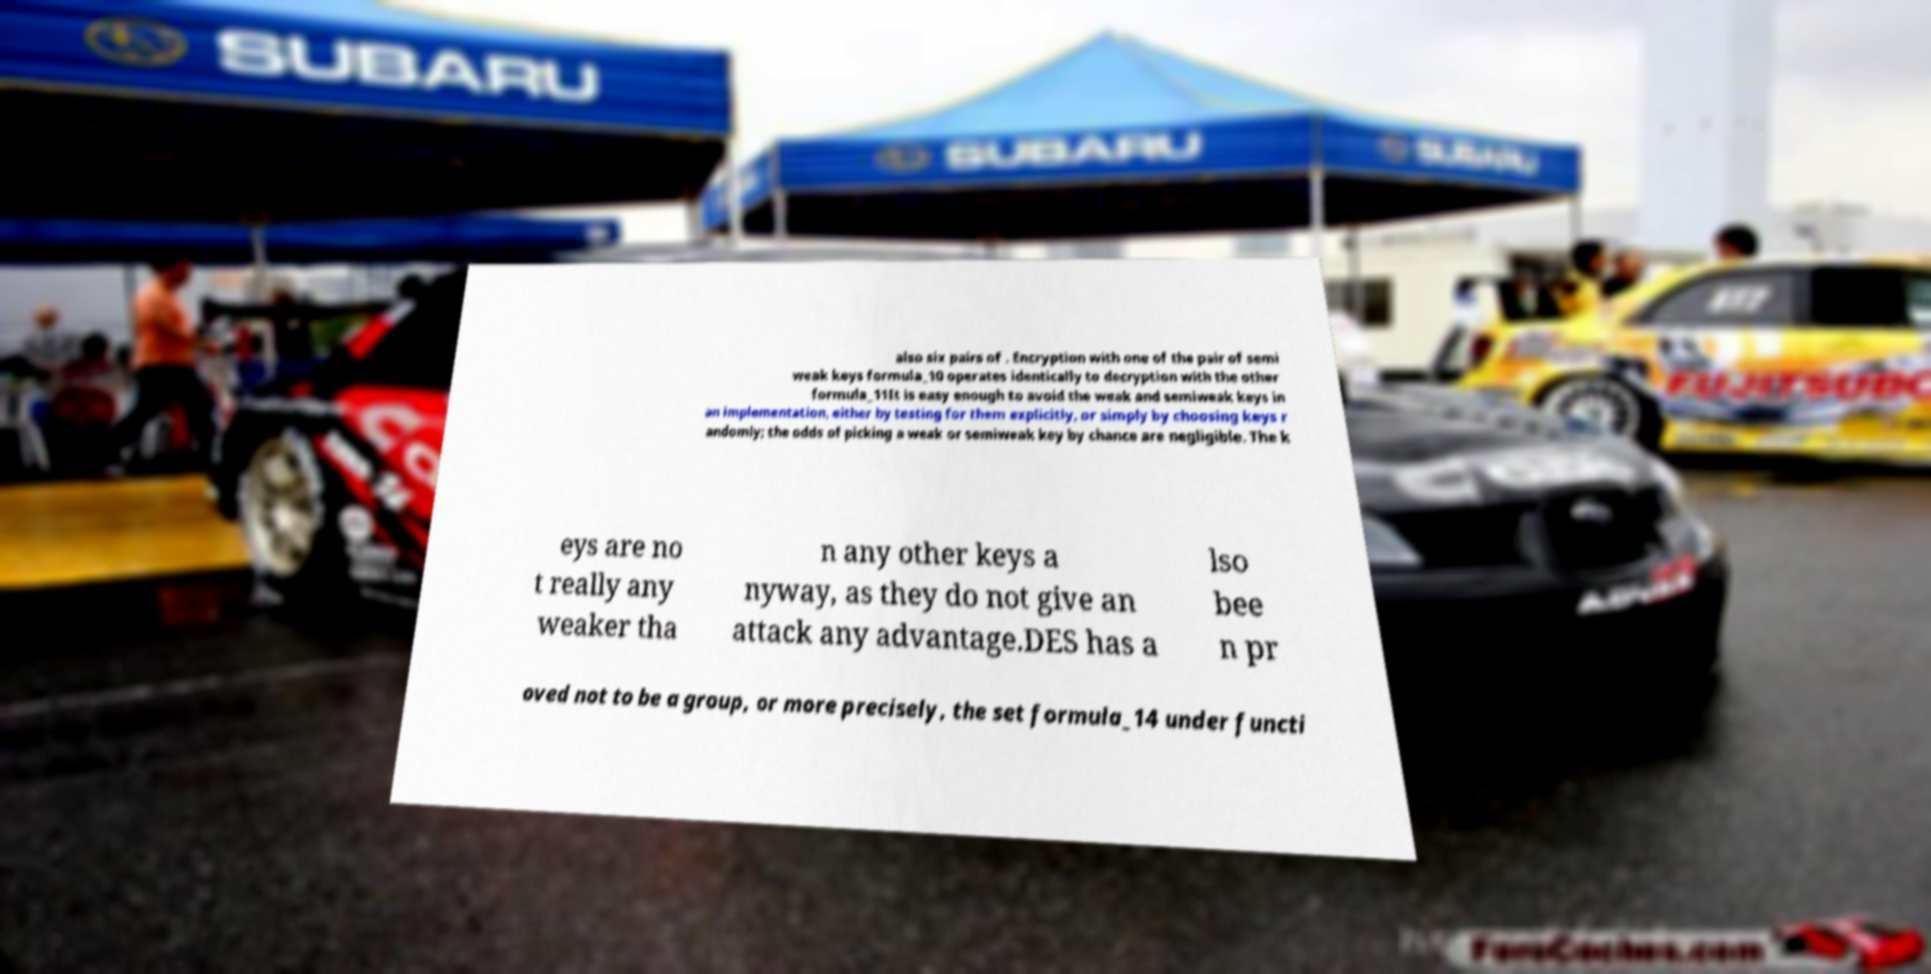For documentation purposes, I need the text within this image transcribed. Could you provide that? also six pairs of . Encryption with one of the pair of semi weak keys formula_10 operates identically to decryption with the other formula_11It is easy enough to avoid the weak and semiweak keys in an implementation, either by testing for them explicitly, or simply by choosing keys r andomly; the odds of picking a weak or semiweak key by chance are negligible. The k eys are no t really any weaker tha n any other keys a nyway, as they do not give an attack any advantage.DES has a lso bee n pr oved not to be a group, or more precisely, the set formula_14 under functi 